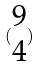Convert formula to latex. <formula><loc_0><loc_0><loc_500><loc_500>( \begin{matrix} 9 \\ 4 \end{matrix} )</formula> 